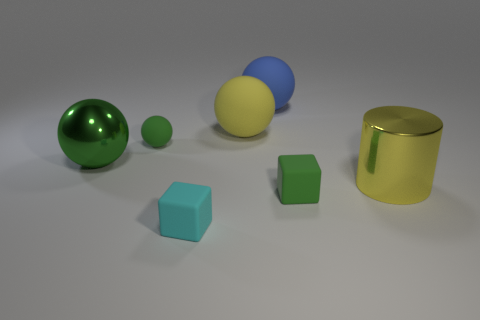Subtract all small green balls. How many balls are left? 3 Add 1 tiny green rubber blocks. How many objects exist? 8 Subtract all red cylinders. How many green spheres are left? 2 Subtract all blue spheres. How many spheres are left? 3 Subtract 1 spheres. How many spheres are left? 3 Subtract 0 gray balls. How many objects are left? 7 Subtract all cylinders. How many objects are left? 6 Subtract all blue cubes. Subtract all green cylinders. How many cubes are left? 2 Subtract all tiny green things. Subtract all blue rubber objects. How many objects are left? 4 Add 4 green rubber blocks. How many green rubber blocks are left? 5 